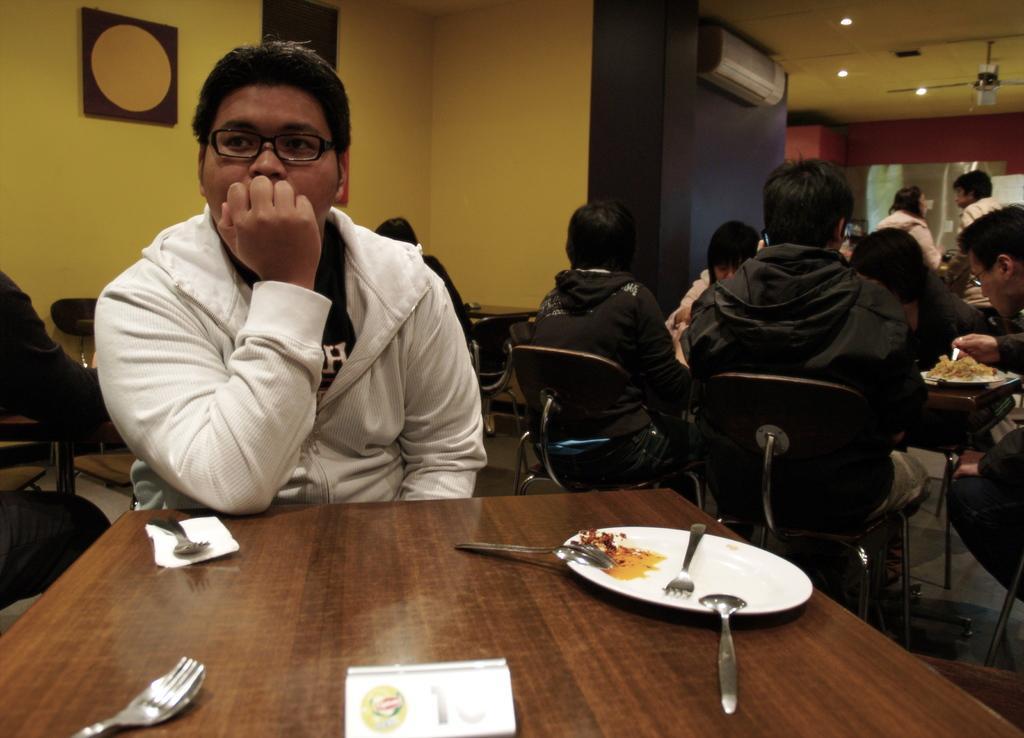Describe this image in one or two sentences. In this image there is a man with white jacket sitting behind the table. There is plate, fork, spoon and a tissue on the table. At the right side of the image there are group of people and at the top right there is a conditioner and a light 